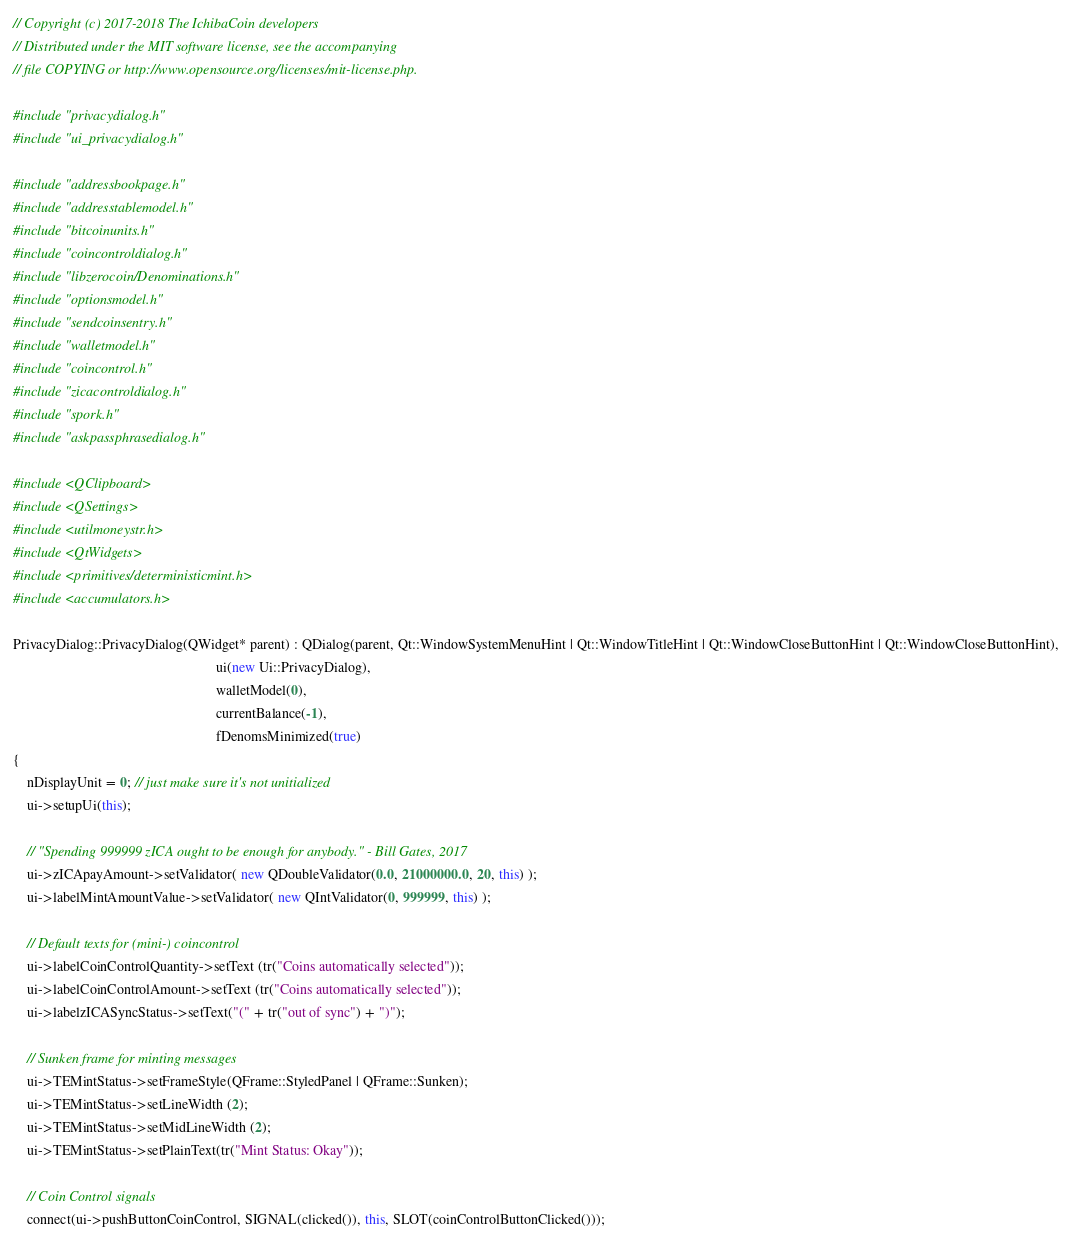<code> <loc_0><loc_0><loc_500><loc_500><_C++_>// Copyright (c) 2017-2018 The IchibaCoin developers
// Distributed under the MIT software license, see the accompanying
// file COPYING or http://www.opensource.org/licenses/mit-license.php.

#include "privacydialog.h"
#include "ui_privacydialog.h"

#include "addressbookpage.h"
#include "addresstablemodel.h"
#include "bitcoinunits.h"
#include "coincontroldialog.h"
#include "libzerocoin/Denominations.h"
#include "optionsmodel.h"
#include "sendcoinsentry.h"
#include "walletmodel.h"
#include "coincontrol.h"
#include "zicacontroldialog.h"
#include "spork.h"
#include "askpassphrasedialog.h"

#include <QClipboard>
#include <QSettings>
#include <utilmoneystr.h>
#include <QtWidgets>
#include <primitives/deterministicmint.h>
#include <accumulators.h>

PrivacyDialog::PrivacyDialog(QWidget* parent) : QDialog(parent, Qt::WindowSystemMenuHint | Qt::WindowTitleHint | Qt::WindowCloseButtonHint | Qt::WindowCloseButtonHint),
                                                          ui(new Ui::PrivacyDialog),
                                                          walletModel(0),
                                                          currentBalance(-1),
                                                          fDenomsMinimized(true)
{
    nDisplayUnit = 0; // just make sure it's not unitialized
    ui->setupUi(this);

    // "Spending 999999 zICA ought to be enough for anybody." - Bill Gates, 2017
    ui->zICApayAmount->setValidator( new QDoubleValidator(0.0, 21000000.0, 20, this) );
    ui->labelMintAmountValue->setValidator( new QIntValidator(0, 999999, this) );

    // Default texts for (mini-) coincontrol
    ui->labelCoinControlQuantity->setText (tr("Coins automatically selected"));
    ui->labelCoinControlAmount->setText (tr("Coins automatically selected"));
    ui->labelzICASyncStatus->setText("(" + tr("out of sync") + ")");

    // Sunken frame for minting messages
    ui->TEMintStatus->setFrameStyle(QFrame::StyledPanel | QFrame::Sunken);
    ui->TEMintStatus->setLineWidth (2);
    ui->TEMintStatus->setMidLineWidth (2);
    ui->TEMintStatus->setPlainText(tr("Mint Status: Okay"));

    // Coin Control signals
    connect(ui->pushButtonCoinControl, SIGNAL(clicked()), this, SLOT(coinControlButtonClicked()));
</code> 